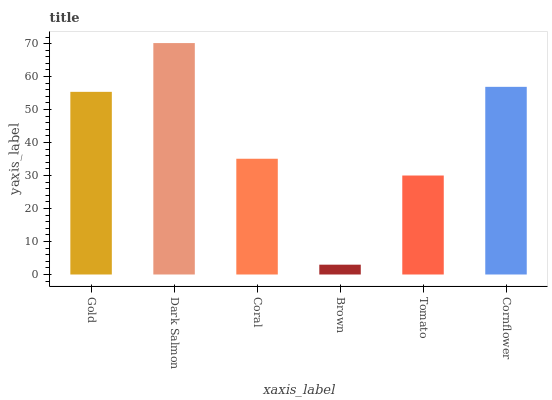Is Brown the minimum?
Answer yes or no. Yes. Is Dark Salmon the maximum?
Answer yes or no. Yes. Is Coral the minimum?
Answer yes or no. No. Is Coral the maximum?
Answer yes or no. No. Is Dark Salmon greater than Coral?
Answer yes or no. Yes. Is Coral less than Dark Salmon?
Answer yes or no. Yes. Is Coral greater than Dark Salmon?
Answer yes or no. No. Is Dark Salmon less than Coral?
Answer yes or no. No. Is Gold the high median?
Answer yes or no. Yes. Is Coral the low median?
Answer yes or no. Yes. Is Cornflower the high median?
Answer yes or no. No. Is Brown the low median?
Answer yes or no. No. 